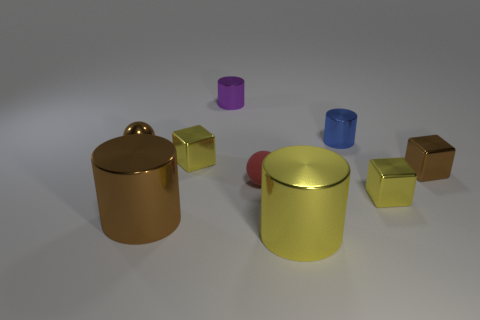The block that is the same color as the metallic ball is what size?
Make the answer very short. Small. Are the tiny cube that is to the left of the tiny purple metal cylinder and the small purple thing made of the same material?
Your answer should be very brief. Yes. What number of things are large brown rubber cylinders or metallic objects?
Keep it short and to the point. 8. The yellow shiny thing that is the same shape as the purple object is what size?
Ensure brevity in your answer.  Large. The blue metallic object is what size?
Keep it short and to the point. Small. Is the number of yellow blocks that are left of the rubber thing greater than the number of big metal balls?
Ensure brevity in your answer.  Yes. Are there any other things that have the same material as the red sphere?
Ensure brevity in your answer.  No. Does the large metal cylinder in front of the big brown metal cylinder have the same color as the cube that is left of the yellow shiny cylinder?
Offer a terse response. Yes. What is the tiny yellow block behind the ball that is in front of the small shiny cube that is on the left side of the blue shiny cylinder made of?
Provide a succinct answer. Metal. Is the number of tiny red rubber things greater than the number of tiny blocks?
Your response must be concise. No. 